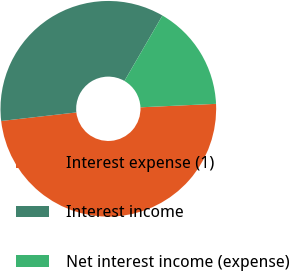Convert chart. <chart><loc_0><loc_0><loc_500><loc_500><pie_chart><fcel>Interest expense (1)<fcel>Interest income<fcel>Net interest income (expense)<nl><fcel>48.93%<fcel>35.17%<fcel>15.9%<nl></chart> 